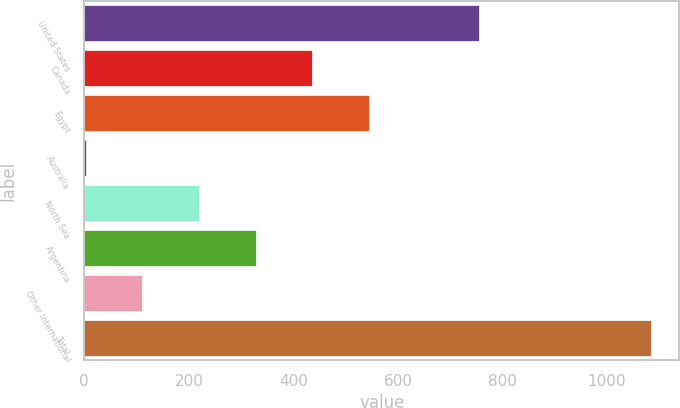Convert chart. <chart><loc_0><loc_0><loc_500><loc_500><bar_chart><fcel>United States<fcel>Canada<fcel>Egypt<fcel>Australia<fcel>North Sea<fcel>Argentina<fcel>Other International<fcel>Total<nl><fcel>755.5<fcel>435.68<fcel>543.8<fcel>3.2<fcel>219.44<fcel>327.56<fcel>111.32<fcel>1084.4<nl></chart> 